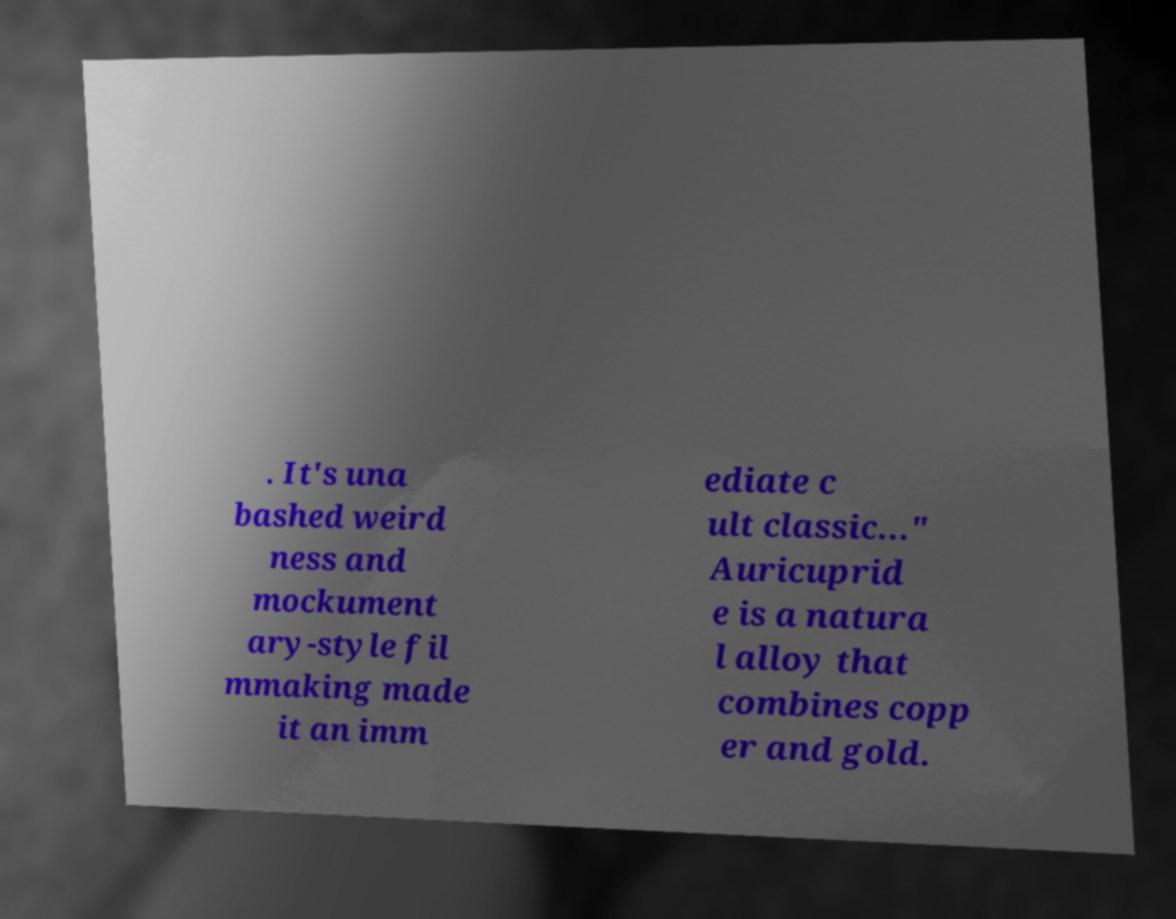Could you assist in decoding the text presented in this image and type it out clearly? . It's una bashed weird ness and mockument ary-style fil mmaking made it an imm ediate c ult classic..." Auricuprid e is a natura l alloy that combines copp er and gold. 